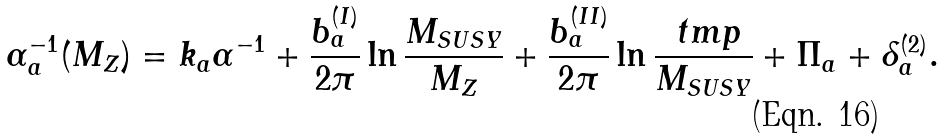Convert formula to latex. <formula><loc_0><loc_0><loc_500><loc_500>\alpha _ { a } ^ { - 1 } ( M _ { Z } ) = k _ { a } \alpha ^ { - 1 } + \frac { b _ { a } ^ { ( I ) } } { 2 \pi } \ln \frac { M _ { S U S Y } } { M _ { Z } } + \frac { b _ { a } ^ { ( I I ) } } { 2 \pi } \ln \frac { \ t m p } { M _ { S U S Y } } + \Pi _ { a } + \delta _ { a } ^ { ( 2 ) } .</formula> 